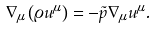<formula> <loc_0><loc_0><loc_500><loc_500>\nabla _ { \mu } \left ( \varrho u ^ { \mu } \right ) = - \tilde { p } \nabla _ { \mu } u ^ { \mu } .</formula> 